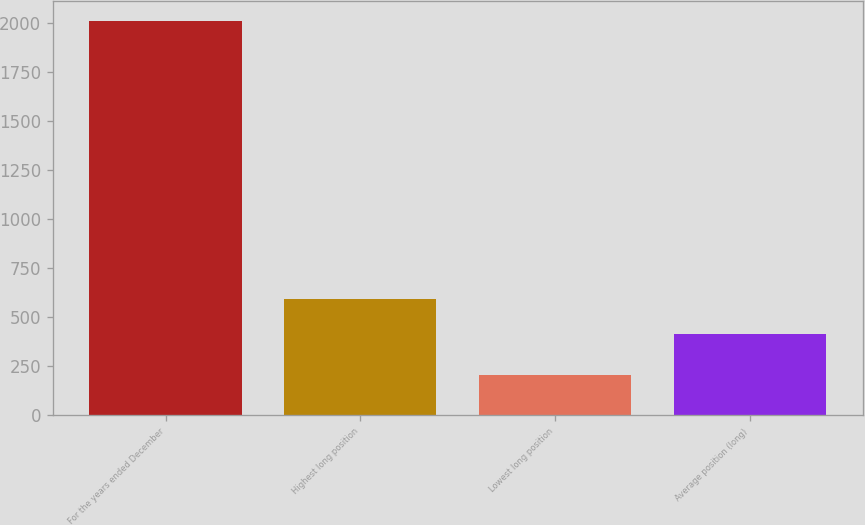Convert chart to OTSL. <chart><loc_0><loc_0><loc_500><loc_500><bar_chart><fcel>For the years ended December<fcel>Highest long position<fcel>Lowest long position<fcel>Average position (long)<nl><fcel>2011<fcel>593.72<fcel>204.8<fcel>413.1<nl></chart> 